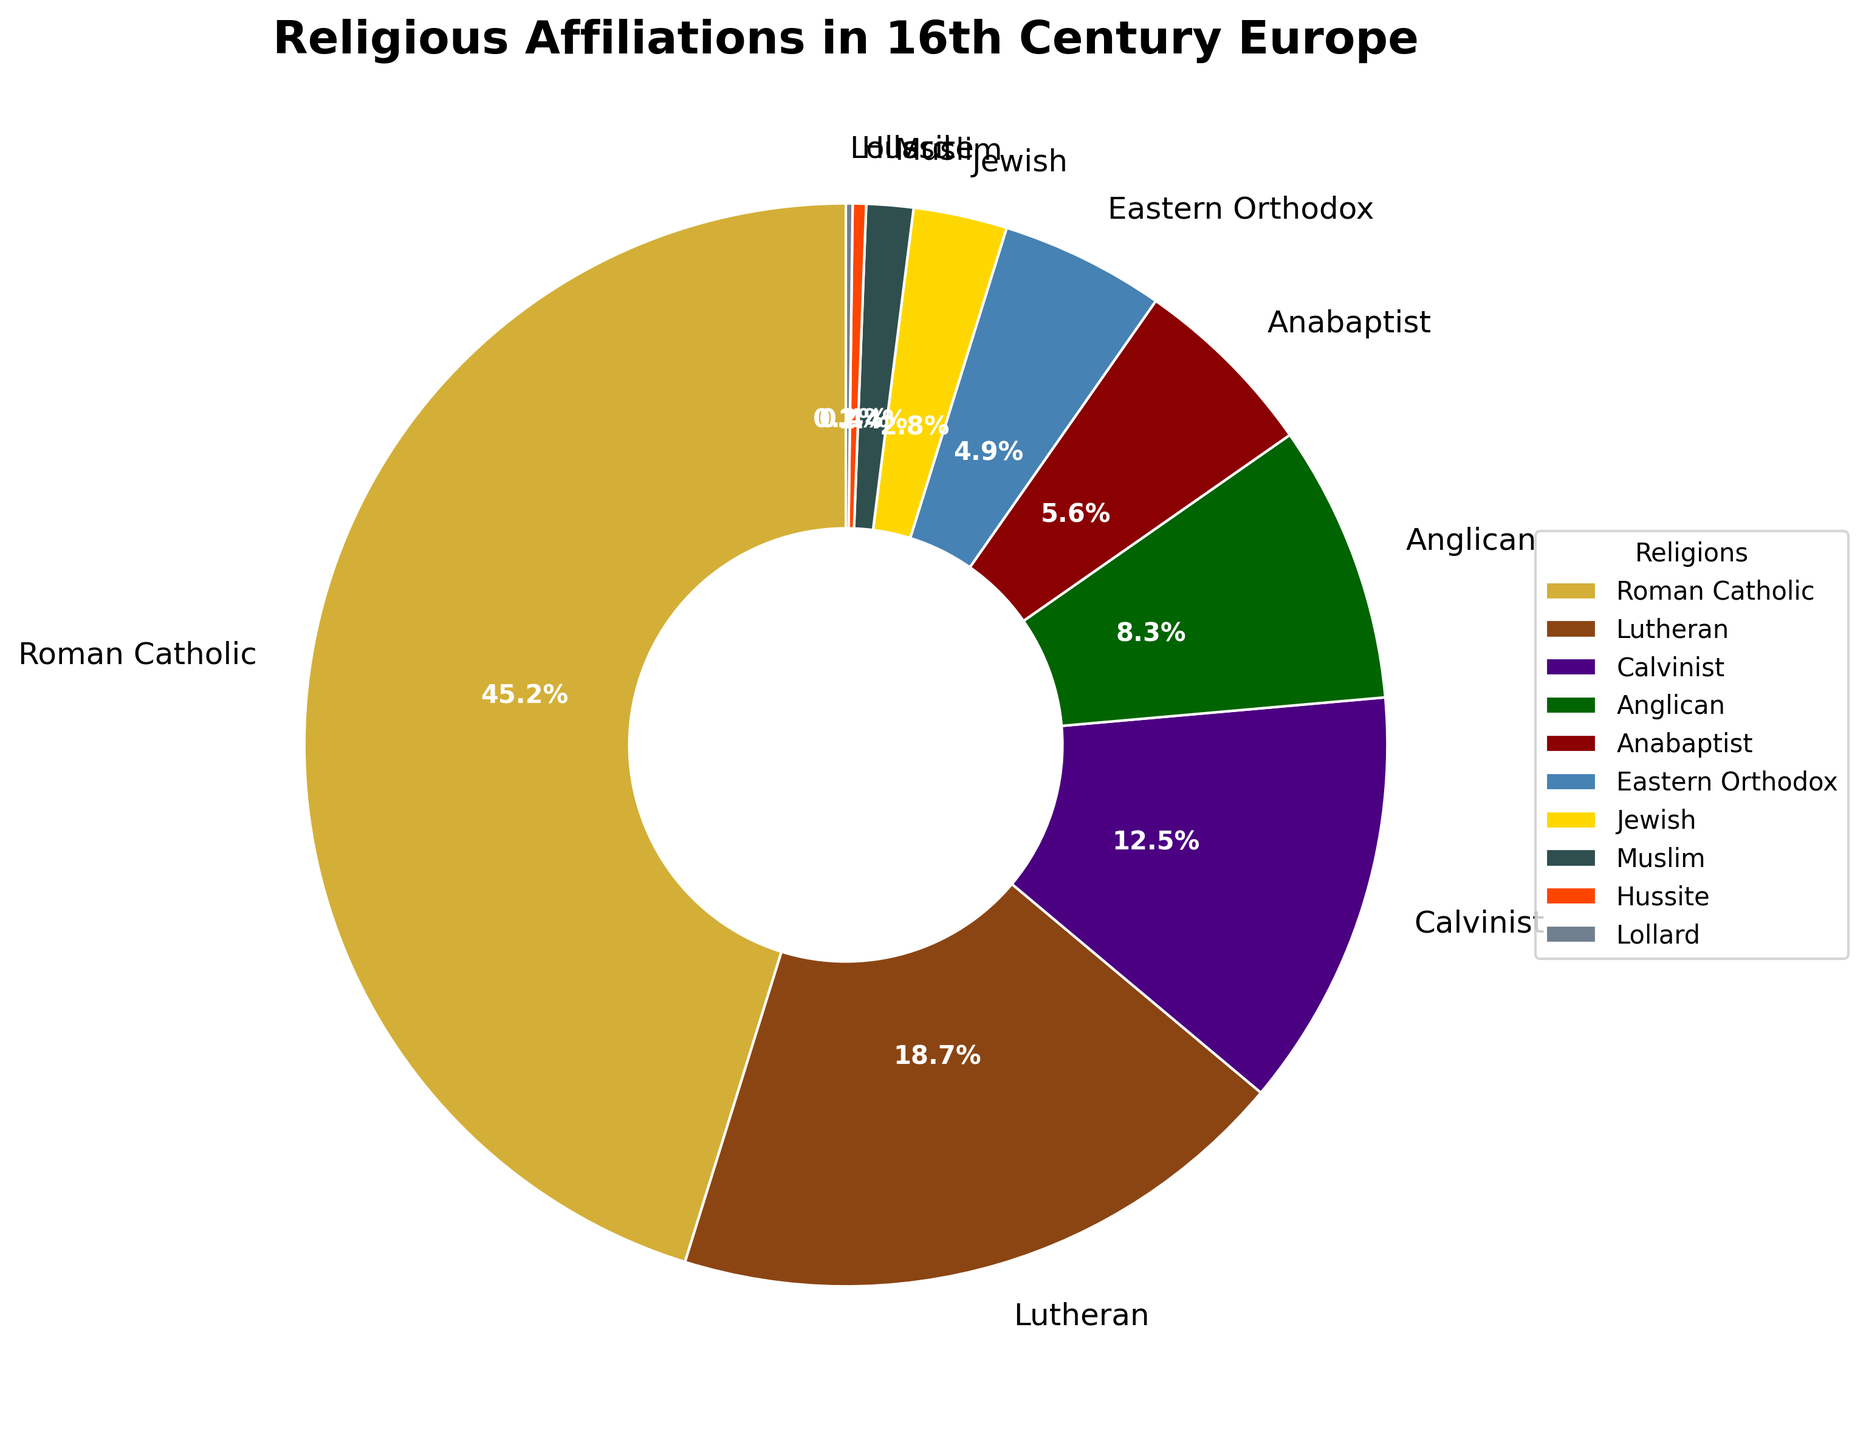What is the largest religious affiliation shown in the pie chart? The pie chart shows that the Roman Catholic segment is the largest, representing 45.2%.
Answer: Roman Catholic Which religious group has the smallest representation in the pie chart? By observing the smallest wedge in the pie chart, it is evident that the Lollard group represents only 0.2%.
Answer: Lollard What is the combined percentage of Lutheran and Calvinist affiliations? Lutheran represents 18.7% and Calvinist represents 12.5%. Adding these two percentages together yields 18.7% + 12.5% = 31.2%.
Answer: 31.2% How much greater is the Roman Catholic percentage compared to the Anglican percentage? Roman Catholic is 45.2%, and Anglican is 8.3%. The difference is calculated by subtracting the Anglican percentage from the Roman Catholic percentage: 45.2% - 8.3% = 36.9%.
Answer: 36.9% Which religious affiliation has a smaller share than Anabaptist but larger than Muslim? The pie chart shows that Anabaptist is 5.6%, and Muslim is 1.4%. The group with a percentage between these two is Eastern Orthodox at 4.9%.
Answer: Eastern Orthodox What two religious groups together make up approximately 10% of the chart? The sum of the percentages for Anabaptist (5.6%) and Jewish (2.8%) equals 5.6% + 2.8% = 8.4%, which is the closest to 10% when considering only pairs.
Answer: Anabaptist and Jewish What visual color is the Eastern Orthodox wedge? The pie chart uses different colors for each affiliation. The Eastern Orthodox wedge is colored in blue.
Answer: Blue How many more times is the percentage of Roman Catholic compared to Lollard? The Roman Catholic percentage is 45.2%, and the Lollard percentage is 0.2%. To find how many times greater the Roman Catholic percentage is, divide 45.2 by 0.2, which is 45.2 / 0.2 = 226 times.
Answer: 226 times Which religious groups combined constitute less than 5% of the affiliations shown? Lollard (0.2%) and Hussite (0.4%) together total 0.6%, which is less than 5%.
Answer: Lollard and Hussite 